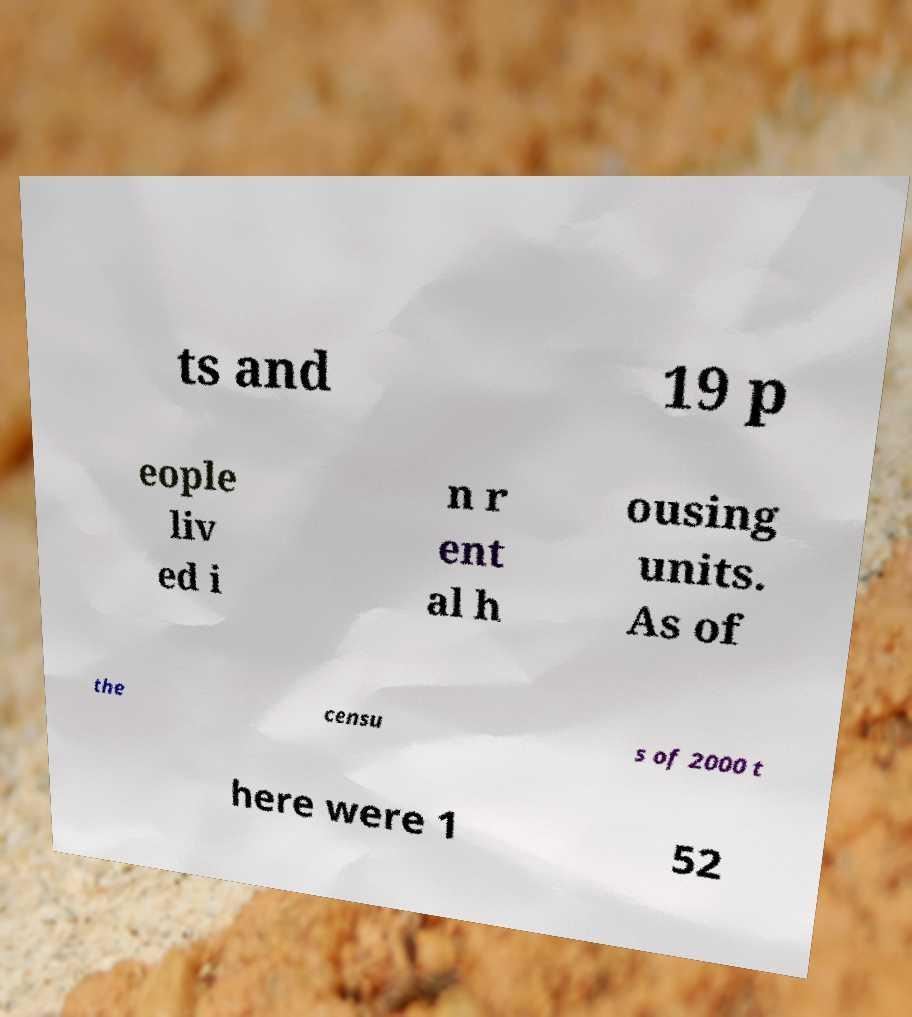For documentation purposes, I need the text within this image transcribed. Could you provide that? ts and 19 p eople liv ed i n r ent al h ousing units. As of the censu s of 2000 t here were 1 52 